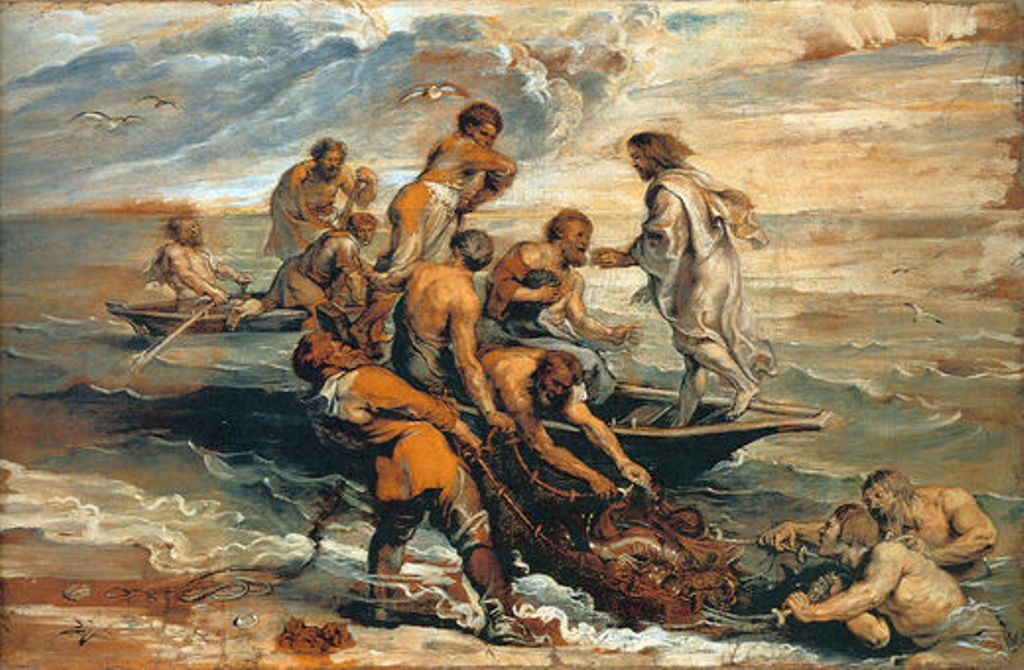What historical or mythological story might this painting be depicting? This painting likely depicts a scene from classical mythology, involving gods and heroes. The tumultuous ocean setting and the struggle with a sea creature may reference tales from Greek mythology, such as the trials of Heracles or the adventures of Perseus. Such themes were popular in Baroque art, used to convey human emotions and divine interventions. 